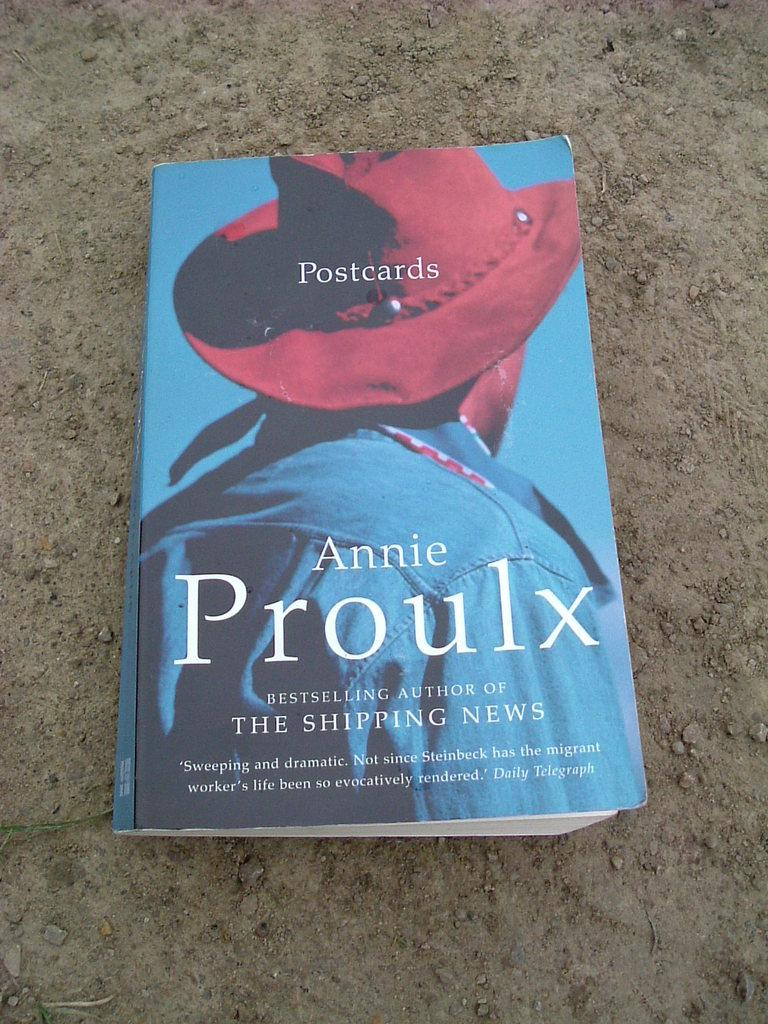<image>
Render a clear and concise summary of the photo. Annie Proulx write a novel called Postcards featuring  a man in a red hat on the cover 